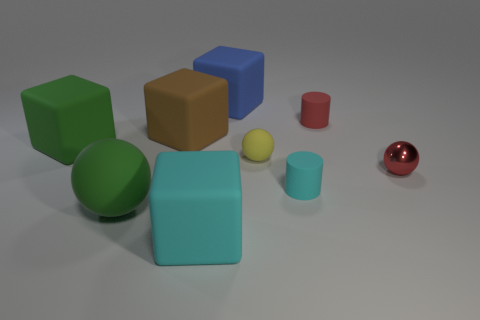Is there anything else that is the same material as the red sphere?
Your response must be concise. No. There is a small yellow thing that is the same shape as the red metallic thing; what material is it?
Your response must be concise. Rubber. What is the shape of the small red object that is to the right of the tiny matte object behind the rubber ball to the right of the blue object?
Give a very brief answer. Sphere. Is the number of green things that are in front of the small cyan rubber object greater than the number of tiny cyan rubber spheres?
Offer a very short reply. Yes. Does the large green object behind the yellow matte sphere have the same shape as the blue rubber object?
Your response must be concise. Yes. There is a cylinder in front of the big brown object; what material is it?
Ensure brevity in your answer.  Rubber. How many large green objects are the same shape as the tiny yellow thing?
Offer a very short reply. 1. There is a large block in front of the matte ball that is to the right of the blue block; what is it made of?
Provide a succinct answer. Rubber. What is the shape of the large object that is the same color as the large sphere?
Provide a short and direct response. Cube. Are there any tiny objects that have the same material as the large ball?
Your answer should be compact. Yes. 